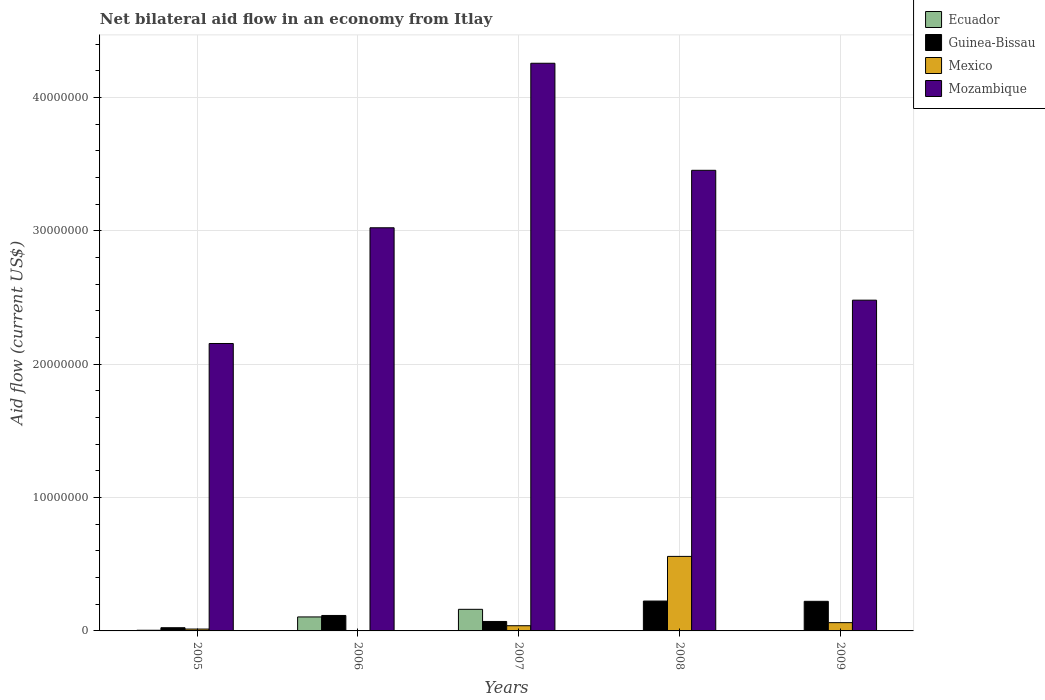How many different coloured bars are there?
Offer a terse response. 4. Are the number of bars per tick equal to the number of legend labels?
Your answer should be very brief. No. How many bars are there on the 3rd tick from the right?
Your answer should be compact. 4. What is the label of the 1st group of bars from the left?
Provide a succinct answer. 2005. In how many cases, is the number of bars for a given year not equal to the number of legend labels?
Provide a short and direct response. 2. What is the net bilateral aid flow in Mexico in 2008?
Provide a succinct answer. 5.59e+06. Across all years, what is the maximum net bilateral aid flow in Mexico?
Offer a very short reply. 5.59e+06. In which year was the net bilateral aid flow in Guinea-Bissau maximum?
Your answer should be compact. 2008. What is the total net bilateral aid flow in Ecuador in the graph?
Ensure brevity in your answer.  2.72e+06. What is the difference between the net bilateral aid flow in Mexico in 2006 and that in 2008?
Offer a terse response. -5.57e+06. What is the difference between the net bilateral aid flow in Mozambique in 2005 and the net bilateral aid flow in Mexico in 2006?
Keep it short and to the point. 2.15e+07. What is the average net bilateral aid flow in Guinea-Bissau per year?
Provide a short and direct response. 1.31e+06. In the year 2009, what is the difference between the net bilateral aid flow in Mexico and net bilateral aid flow in Guinea-Bissau?
Make the answer very short. -1.60e+06. In how many years, is the net bilateral aid flow in Ecuador greater than 38000000 US$?
Ensure brevity in your answer.  0. What is the ratio of the net bilateral aid flow in Mexico in 2005 to that in 2008?
Make the answer very short. 0.03. Is the net bilateral aid flow in Mozambique in 2006 less than that in 2007?
Provide a short and direct response. Yes. Is the difference between the net bilateral aid flow in Mexico in 2007 and 2008 greater than the difference between the net bilateral aid flow in Guinea-Bissau in 2007 and 2008?
Make the answer very short. No. What is the difference between the highest and the second highest net bilateral aid flow in Guinea-Bissau?
Keep it short and to the point. 2.00e+04. What is the difference between the highest and the lowest net bilateral aid flow in Mozambique?
Provide a short and direct response. 2.10e+07. In how many years, is the net bilateral aid flow in Ecuador greater than the average net bilateral aid flow in Ecuador taken over all years?
Offer a very short reply. 2. Is the sum of the net bilateral aid flow in Mexico in 2007 and 2009 greater than the maximum net bilateral aid flow in Mozambique across all years?
Your answer should be very brief. No. How many bars are there?
Offer a very short reply. 18. How many years are there in the graph?
Provide a succinct answer. 5. What is the difference between two consecutive major ticks on the Y-axis?
Ensure brevity in your answer.  1.00e+07. Does the graph contain grids?
Offer a terse response. Yes. Where does the legend appear in the graph?
Keep it short and to the point. Top right. What is the title of the graph?
Provide a short and direct response. Net bilateral aid flow in an economy from Itlay. Does "Central African Republic" appear as one of the legend labels in the graph?
Provide a short and direct response. No. What is the label or title of the X-axis?
Your answer should be compact. Years. What is the Aid flow (current US$) of Ecuador in 2005?
Your answer should be very brief. 5.00e+04. What is the Aid flow (current US$) in Mexico in 2005?
Give a very brief answer. 1.40e+05. What is the Aid flow (current US$) of Mozambique in 2005?
Your answer should be very brief. 2.16e+07. What is the Aid flow (current US$) in Ecuador in 2006?
Offer a very short reply. 1.05e+06. What is the Aid flow (current US$) in Guinea-Bissau in 2006?
Ensure brevity in your answer.  1.16e+06. What is the Aid flow (current US$) in Mozambique in 2006?
Offer a very short reply. 3.02e+07. What is the Aid flow (current US$) in Ecuador in 2007?
Ensure brevity in your answer.  1.62e+06. What is the Aid flow (current US$) of Guinea-Bissau in 2007?
Provide a short and direct response. 7.10e+05. What is the Aid flow (current US$) of Mexico in 2007?
Make the answer very short. 3.90e+05. What is the Aid flow (current US$) of Mozambique in 2007?
Provide a succinct answer. 4.26e+07. What is the Aid flow (current US$) in Guinea-Bissau in 2008?
Offer a terse response. 2.24e+06. What is the Aid flow (current US$) of Mexico in 2008?
Provide a short and direct response. 5.59e+06. What is the Aid flow (current US$) in Mozambique in 2008?
Your answer should be very brief. 3.46e+07. What is the Aid flow (current US$) of Guinea-Bissau in 2009?
Ensure brevity in your answer.  2.22e+06. What is the Aid flow (current US$) of Mexico in 2009?
Your answer should be compact. 6.20e+05. What is the Aid flow (current US$) in Mozambique in 2009?
Keep it short and to the point. 2.48e+07. Across all years, what is the maximum Aid flow (current US$) of Ecuador?
Your response must be concise. 1.62e+06. Across all years, what is the maximum Aid flow (current US$) in Guinea-Bissau?
Your response must be concise. 2.24e+06. Across all years, what is the maximum Aid flow (current US$) in Mexico?
Your answer should be compact. 5.59e+06. Across all years, what is the maximum Aid flow (current US$) in Mozambique?
Your response must be concise. 4.26e+07. Across all years, what is the minimum Aid flow (current US$) of Ecuador?
Offer a terse response. 0. Across all years, what is the minimum Aid flow (current US$) of Guinea-Bissau?
Your response must be concise. 2.40e+05. Across all years, what is the minimum Aid flow (current US$) of Mozambique?
Give a very brief answer. 2.16e+07. What is the total Aid flow (current US$) of Ecuador in the graph?
Your answer should be compact. 2.72e+06. What is the total Aid flow (current US$) in Guinea-Bissau in the graph?
Offer a terse response. 6.57e+06. What is the total Aid flow (current US$) of Mexico in the graph?
Offer a terse response. 6.76e+06. What is the total Aid flow (current US$) of Mozambique in the graph?
Give a very brief answer. 1.54e+08. What is the difference between the Aid flow (current US$) in Guinea-Bissau in 2005 and that in 2006?
Keep it short and to the point. -9.20e+05. What is the difference between the Aid flow (current US$) in Mexico in 2005 and that in 2006?
Provide a short and direct response. 1.20e+05. What is the difference between the Aid flow (current US$) of Mozambique in 2005 and that in 2006?
Your answer should be very brief. -8.68e+06. What is the difference between the Aid flow (current US$) in Ecuador in 2005 and that in 2007?
Your answer should be compact. -1.57e+06. What is the difference between the Aid flow (current US$) of Guinea-Bissau in 2005 and that in 2007?
Keep it short and to the point. -4.70e+05. What is the difference between the Aid flow (current US$) of Mexico in 2005 and that in 2007?
Make the answer very short. -2.50e+05. What is the difference between the Aid flow (current US$) of Mozambique in 2005 and that in 2007?
Ensure brevity in your answer.  -2.10e+07. What is the difference between the Aid flow (current US$) of Guinea-Bissau in 2005 and that in 2008?
Make the answer very short. -2.00e+06. What is the difference between the Aid flow (current US$) in Mexico in 2005 and that in 2008?
Keep it short and to the point. -5.45e+06. What is the difference between the Aid flow (current US$) of Mozambique in 2005 and that in 2008?
Your answer should be compact. -1.30e+07. What is the difference between the Aid flow (current US$) in Guinea-Bissau in 2005 and that in 2009?
Your answer should be very brief. -1.98e+06. What is the difference between the Aid flow (current US$) in Mexico in 2005 and that in 2009?
Ensure brevity in your answer.  -4.80e+05. What is the difference between the Aid flow (current US$) in Mozambique in 2005 and that in 2009?
Your response must be concise. -3.25e+06. What is the difference between the Aid flow (current US$) in Ecuador in 2006 and that in 2007?
Make the answer very short. -5.70e+05. What is the difference between the Aid flow (current US$) of Guinea-Bissau in 2006 and that in 2007?
Provide a succinct answer. 4.50e+05. What is the difference between the Aid flow (current US$) in Mexico in 2006 and that in 2007?
Your answer should be compact. -3.70e+05. What is the difference between the Aid flow (current US$) in Mozambique in 2006 and that in 2007?
Make the answer very short. -1.23e+07. What is the difference between the Aid flow (current US$) of Guinea-Bissau in 2006 and that in 2008?
Your answer should be compact. -1.08e+06. What is the difference between the Aid flow (current US$) in Mexico in 2006 and that in 2008?
Ensure brevity in your answer.  -5.57e+06. What is the difference between the Aid flow (current US$) of Mozambique in 2006 and that in 2008?
Give a very brief answer. -4.31e+06. What is the difference between the Aid flow (current US$) in Guinea-Bissau in 2006 and that in 2009?
Your answer should be very brief. -1.06e+06. What is the difference between the Aid flow (current US$) of Mexico in 2006 and that in 2009?
Ensure brevity in your answer.  -6.00e+05. What is the difference between the Aid flow (current US$) of Mozambique in 2006 and that in 2009?
Ensure brevity in your answer.  5.43e+06. What is the difference between the Aid flow (current US$) in Guinea-Bissau in 2007 and that in 2008?
Provide a succinct answer. -1.53e+06. What is the difference between the Aid flow (current US$) of Mexico in 2007 and that in 2008?
Provide a succinct answer. -5.20e+06. What is the difference between the Aid flow (current US$) of Mozambique in 2007 and that in 2008?
Make the answer very short. 8.03e+06. What is the difference between the Aid flow (current US$) of Guinea-Bissau in 2007 and that in 2009?
Provide a short and direct response. -1.51e+06. What is the difference between the Aid flow (current US$) of Mozambique in 2007 and that in 2009?
Offer a terse response. 1.78e+07. What is the difference between the Aid flow (current US$) of Mexico in 2008 and that in 2009?
Keep it short and to the point. 4.97e+06. What is the difference between the Aid flow (current US$) in Mozambique in 2008 and that in 2009?
Give a very brief answer. 9.74e+06. What is the difference between the Aid flow (current US$) in Ecuador in 2005 and the Aid flow (current US$) in Guinea-Bissau in 2006?
Your answer should be compact. -1.11e+06. What is the difference between the Aid flow (current US$) in Ecuador in 2005 and the Aid flow (current US$) in Mozambique in 2006?
Provide a short and direct response. -3.02e+07. What is the difference between the Aid flow (current US$) in Guinea-Bissau in 2005 and the Aid flow (current US$) in Mozambique in 2006?
Give a very brief answer. -3.00e+07. What is the difference between the Aid flow (current US$) of Mexico in 2005 and the Aid flow (current US$) of Mozambique in 2006?
Provide a short and direct response. -3.01e+07. What is the difference between the Aid flow (current US$) of Ecuador in 2005 and the Aid flow (current US$) of Guinea-Bissau in 2007?
Your answer should be very brief. -6.60e+05. What is the difference between the Aid flow (current US$) of Ecuador in 2005 and the Aid flow (current US$) of Mozambique in 2007?
Your answer should be compact. -4.25e+07. What is the difference between the Aid flow (current US$) in Guinea-Bissau in 2005 and the Aid flow (current US$) in Mozambique in 2007?
Give a very brief answer. -4.23e+07. What is the difference between the Aid flow (current US$) of Mexico in 2005 and the Aid flow (current US$) of Mozambique in 2007?
Your answer should be compact. -4.24e+07. What is the difference between the Aid flow (current US$) in Ecuador in 2005 and the Aid flow (current US$) in Guinea-Bissau in 2008?
Provide a short and direct response. -2.19e+06. What is the difference between the Aid flow (current US$) in Ecuador in 2005 and the Aid flow (current US$) in Mexico in 2008?
Keep it short and to the point. -5.54e+06. What is the difference between the Aid flow (current US$) of Ecuador in 2005 and the Aid flow (current US$) of Mozambique in 2008?
Give a very brief answer. -3.45e+07. What is the difference between the Aid flow (current US$) in Guinea-Bissau in 2005 and the Aid flow (current US$) in Mexico in 2008?
Provide a succinct answer. -5.35e+06. What is the difference between the Aid flow (current US$) of Guinea-Bissau in 2005 and the Aid flow (current US$) of Mozambique in 2008?
Give a very brief answer. -3.43e+07. What is the difference between the Aid flow (current US$) in Mexico in 2005 and the Aid flow (current US$) in Mozambique in 2008?
Your answer should be very brief. -3.44e+07. What is the difference between the Aid flow (current US$) in Ecuador in 2005 and the Aid flow (current US$) in Guinea-Bissau in 2009?
Keep it short and to the point. -2.17e+06. What is the difference between the Aid flow (current US$) of Ecuador in 2005 and the Aid flow (current US$) of Mexico in 2009?
Keep it short and to the point. -5.70e+05. What is the difference between the Aid flow (current US$) of Ecuador in 2005 and the Aid flow (current US$) of Mozambique in 2009?
Your answer should be very brief. -2.48e+07. What is the difference between the Aid flow (current US$) of Guinea-Bissau in 2005 and the Aid flow (current US$) of Mexico in 2009?
Keep it short and to the point. -3.80e+05. What is the difference between the Aid flow (current US$) in Guinea-Bissau in 2005 and the Aid flow (current US$) in Mozambique in 2009?
Keep it short and to the point. -2.46e+07. What is the difference between the Aid flow (current US$) in Mexico in 2005 and the Aid flow (current US$) in Mozambique in 2009?
Offer a very short reply. -2.47e+07. What is the difference between the Aid flow (current US$) in Ecuador in 2006 and the Aid flow (current US$) in Guinea-Bissau in 2007?
Offer a terse response. 3.40e+05. What is the difference between the Aid flow (current US$) in Ecuador in 2006 and the Aid flow (current US$) in Mozambique in 2007?
Provide a succinct answer. -4.15e+07. What is the difference between the Aid flow (current US$) in Guinea-Bissau in 2006 and the Aid flow (current US$) in Mexico in 2007?
Provide a succinct answer. 7.70e+05. What is the difference between the Aid flow (current US$) of Guinea-Bissau in 2006 and the Aid flow (current US$) of Mozambique in 2007?
Provide a short and direct response. -4.14e+07. What is the difference between the Aid flow (current US$) of Mexico in 2006 and the Aid flow (current US$) of Mozambique in 2007?
Offer a terse response. -4.26e+07. What is the difference between the Aid flow (current US$) in Ecuador in 2006 and the Aid flow (current US$) in Guinea-Bissau in 2008?
Give a very brief answer. -1.19e+06. What is the difference between the Aid flow (current US$) in Ecuador in 2006 and the Aid flow (current US$) in Mexico in 2008?
Provide a short and direct response. -4.54e+06. What is the difference between the Aid flow (current US$) in Ecuador in 2006 and the Aid flow (current US$) in Mozambique in 2008?
Offer a very short reply. -3.35e+07. What is the difference between the Aid flow (current US$) in Guinea-Bissau in 2006 and the Aid flow (current US$) in Mexico in 2008?
Offer a very short reply. -4.43e+06. What is the difference between the Aid flow (current US$) of Guinea-Bissau in 2006 and the Aid flow (current US$) of Mozambique in 2008?
Make the answer very short. -3.34e+07. What is the difference between the Aid flow (current US$) of Mexico in 2006 and the Aid flow (current US$) of Mozambique in 2008?
Offer a very short reply. -3.45e+07. What is the difference between the Aid flow (current US$) of Ecuador in 2006 and the Aid flow (current US$) of Guinea-Bissau in 2009?
Give a very brief answer. -1.17e+06. What is the difference between the Aid flow (current US$) in Ecuador in 2006 and the Aid flow (current US$) in Mozambique in 2009?
Make the answer very short. -2.38e+07. What is the difference between the Aid flow (current US$) in Guinea-Bissau in 2006 and the Aid flow (current US$) in Mexico in 2009?
Make the answer very short. 5.40e+05. What is the difference between the Aid flow (current US$) of Guinea-Bissau in 2006 and the Aid flow (current US$) of Mozambique in 2009?
Ensure brevity in your answer.  -2.36e+07. What is the difference between the Aid flow (current US$) of Mexico in 2006 and the Aid flow (current US$) of Mozambique in 2009?
Make the answer very short. -2.48e+07. What is the difference between the Aid flow (current US$) in Ecuador in 2007 and the Aid flow (current US$) in Guinea-Bissau in 2008?
Provide a short and direct response. -6.20e+05. What is the difference between the Aid flow (current US$) of Ecuador in 2007 and the Aid flow (current US$) of Mexico in 2008?
Provide a short and direct response. -3.97e+06. What is the difference between the Aid flow (current US$) of Ecuador in 2007 and the Aid flow (current US$) of Mozambique in 2008?
Keep it short and to the point. -3.29e+07. What is the difference between the Aid flow (current US$) in Guinea-Bissau in 2007 and the Aid flow (current US$) in Mexico in 2008?
Make the answer very short. -4.88e+06. What is the difference between the Aid flow (current US$) of Guinea-Bissau in 2007 and the Aid flow (current US$) of Mozambique in 2008?
Provide a succinct answer. -3.38e+07. What is the difference between the Aid flow (current US$) of Mexico in 2007 and the Aid flow (current US$) of Mozambique in 2008?
Your response must be concise. -3.42e+07. What is the difference between the Aid flow (current US$) in Ecuador in 2007 and the Aid flow (current US$) in Guinea-Bissau in 2009?
Keep it short and to the point. -6.00e+05. What is the difference between the Aid flow (current US$) in Ecuador in 2007 and the Aid flow (current US$) in Mozambique in 2009?
Offer a very short reply. -2.32e+07. What is the difference between the Aid flow (current US$) of Guinea-Bissau in 2007 and the Aid flow (current US$) of Mozambique in 2009?
Your response must be concise. -2.41e+07. What is the difference between the Aid flow (current US$) in Mexico in 2007 and the Aid flow (current US$) in Mozambique in 2009?
Keep it short and to the point. -2.44e+07. What is the difference between the Aid flow (current US$) of Guinea-Bissau in 2008 and the Aid flow (current US$) of Mexico in 2009?
Make the answer very short. 1.62e+06. What is the difference between the Aid flow (current US$) in Guinea-Bissau in 2008 and the Aid flow (current US$) in Mozambique in 2009?
Offer a terse response. -2.26e+07. What is the difference between the Aid flow (current US$) of Mexico in 2008 and the Aid flow (current US$) of Mozambique in 2009?
Your response must be concise. -1.92e+07. What is the average Aid flow (current US$) of Ecuador per year?
Make the answer very short. 5.44e+05. What is the average Aid flow (current US$) in Guinea-Bissau per year?
Provide a succinct answer. 1.31e+06. What is the average Aid flow (current US$) in Mexico per year?
Offer a very short reply. 1.35e+06. What is the average Aid flow (current US$) in Mozambique per year?
Keep it short and to the point. 3.07e+07. In the year 2005, what is the difference between the Aid flow (current US$) in Ecuador and Aid flow (current US$) in Mozambique?
Your answer should be compact. -2.15e+07. In the year 2005, what is the difference between the Aid flow (current US$) of Guinea-Bissau and Aid flow (current US$) of Mozambique?
Your answer should be compact. -2.13e+07. In the year 2005, what is the difference between the Aid flow (current US$) of Mexico and Aid flow (current US$) of Mozambique?
Offer a terse response. -2.14e+07. In the year 2006, what is the difference between the Aid flow (current US$) in Ecuador and Aid flow (current US$) in Mexico?
Your response must be concise. 1.03e+06. In the year 2006, what is the difference between the Aid flow (current US$) of Ecuador and Aid flow (current US$) of Mozambique?
Your answer should be compact. -2.92e+07. In the year 2006, what is the difference between the Aid flow (current US$) of Guinea-Bissau and Aid flow (current US$) of Mexico?
Your response must be concise. 1.14e+06. In the year 2006, what is the difference between the Aid flow (current US$) in Guinea-Bissau and Aid flow (current US$) in Mozambique?
Keep it short and to the point. -2.91e+07. In the year 2006, what is the difference between the Aid flow (current US$) in Mexico and Aid flow (current US$) in Mozambique?
Keep it short and to the point. -3.02e+07. In the year 2007, what is the difference between the Aid flow (current US$) of Ecuador and Aid flow (current US$) of Guinea-Bissau?
Your answer should be compact. 9.10e+05. In the year 2007, what is the difference between the Aid flow (current US$) in Ecuador and Aid flow (current US$) in Mexico?
Provide a short and direct response. 1.23e+06. In the year 2007, what is the difference between the Aid flow (current US$) in Ecuador and Aid flow (current US$) in Mozambique?
Provide a short and direct response. -4.10e+07. In the year 2007, what is the difference between the Aid flow (current US$) in Guinea-Bissau and Aid flow (current US$) in Mozambique?
Your answer should be compact. -4.19e+07. In the year 2007, what is the difference between the Aid flow (current US$) of Mexico and Aid flow (current US$) of Mozambique?
Offer a terse response. -4.22e+07. In the year 2008, what is the difference between the Aid flow (current US$) in Guinea-Bissau and Aid flow (current US$) in Mexico?
Your response must be concise. -3.35e+06. In the year 2008, what is the difference between the Aid flow (current US$) in Guinea-Bissau and Aid flow (current US$) in Mozambique?
Provide a short and direct response. -3.23e+07. In the year 2008, what is the difference between the Aid flow (current US$) in Mexico and Aid flow (current US$) in Mozambique?
Ensure brevity in your answer.  -2.90e+07. In the year 2009, what is the difference between the Aid flow (current US$) in Guinea-Bissau and Aid flow (current US$) in Mexico?
Provide a succinct answer. 1.60e+06. In the year 2009, what is the difference between the Aid flow (current US$) in Guinea-Bissau and Aid flow (current US$) in Mozambique?
Provide a short and direct response. -2.26e+07. In the year 2009, what is the difference between the Aid flow (current US$) of Mexico and Aid flow (current US$) of Mozambique?
Ensure brevity in your answer.  -2.42e+07. What is the ratio of the Aid flow (current US$) of Ecuador in 2005 to that in 2006?
Make the answer very short. 0.05. What is the ratio of the Aid flow (current US$) in Guinea-Bissau in 2005 to that in 2006?
Offer a terse response. 0.21. What is the ratio of the Aid flow (current US$) in Mexico in 2005 to that in 2006?
Offer a very short reply. 7. What is the ratio of the Aid flow (current US$) of Mozambique in 2005 to that in 2006?
Your answer should be compact. 0.71. What is the ratio of the Aid flow (current US$) of Ecuador in 2005 to that in 2007?
Keep it short and to the point. 0.03. What is the ratio of the Aid flow (current US$) in Guinea-Bissau in 2005 to that in 2007?
Make the answer very short. 0.34. What is the ratio of the Aid flow (current US$) in Mexico in 2005 to that in 2007?
Make the answer very short. 0.36. What is the ratio of the Aid flow (current US$) in Mozambique in 2005 to that in 2007?
Give a very brief answer. 0.51. What is the ratio of the Aid flow (current US$) in Guinea-Bissau in 2005 to that in 2008?
Keep it short and to the point. 0.11. What is the ratio of the Aid flow (current US$) of Mexico in 2005 to that in 2008?
Give a very brief answer. 0.03. What is the ratio of the Aid flow (current US$) in Mozambique in 2005 to that in 2008?
Give a very brief answer. 0.62. What is the ratio of the Aid flow (current US$) in Guinea-Bissau in 2005 to that in 2009?
Provide a short and direct response. 0.11. What is the ratio of the Aid flow (current US$) in Mexico in 2005 to that in 2009?
Make the answer very short. 0.23. What is the ratio of the Aid flow (current US$) in Mozambique in 2005 to that in 2009?
Your answer should be compact. 0.87. What is the ratio of the Aid flow (current US$) in Ecuador in 2006 to that in 2007?
Give a very brief answer. 0.65. What is the ratio of the Aid flow (current US$) of Guinea-Bissau in 2006 to that in 2007?
Offer a very short reply. 1.63. What is the ratio of the Aid flow (current US$) of Mexico in 2006 to that in 2007?
Provide a succinct answer. 0.05. What is the ratio of the Aid flow (current US$) in Mozambique in 2006 to that in 2007?
Your answer should be compact. 0.71. What is the ratio of the Aid flow (current US$) of Guinea-Bissau in 2006 to that in 2008?
Provide a short and direct response. 0.52. What is the ratio of the Aid flow (current US$) of Mexico in 2006 to that in 2008?
Your answer should be compact. 0. What is the ratio of the Aid flow (current US$) of Mozambique in 2006 to that in 2008?
Provide a succinct answer. 0.88. What is the ratio of the Aid flow (current US$) in Guinea-Bissau in 2006 to that in 2009?
Keep it short and to the point. 0.52. What is the ratio of the Aid flow (current US$) in Mexico in 2006 to that in 2009?
Give a very brief answer. 0.03. What is the ratio of the Aid flow (current US$) of Mozambique in 2006 to that in 2009?
Provide a succinct answer. 1.22. What is the ratio of the Aid flow (current US$) in Guinea-Bissau in 2007 to that in 2008?
Provide a succinct answer. 0.32. What is the ratio of the Aid flow (current US$) of Mexico in 2007 to that in 2008?
Make the answer very short. 0.07. What is the ratio of the Aid flow (current US$) in Mozambique in 2007 to that in 2008?
Your answer should be very brief. 1.23. What is the ratio of the Aid flow (current US$) in Guinea-Bissau in 2007 to that in 2009?
Offer a very short reply. 0.32. What is the ratio of the Aid flow (current US$) of Mexico in 2007 to that in 2009?
Give a very brief answer. 0.63. What is the ratio of the Aid flow (current US$) of Mozambique in 2007 to that in 2009?
Your answer should be very brief. 1.72. What is the ratio of the Aid flow (current US$) of Guinea-Bissau in 2008 to that in 2009?
Make the answer very short. 1.01. What is the ratio of the Aid flow (current US$) in Mexico in 2008 to that in 2009?
Offer a terse response. 9.02. What is the ratio of the Aid flow (current US$) of Mozambique in 2008 to that in 2009?
Give a very brief answer. 1.39. What is the difference between the highest and the second highest Aid flow (current US$) in Ecuador?
Give a very brief answer. 5.70e+05. What is the difference between the highest and the second highest Aid flow (current US$) in Guinea-Bissau?
Give a very brief answer. 2.00e+04. What is the difference between the highest and the second highest Aid flow (current US$) in Mexico?
Provide a short and direct response. 4.97e+06. What is the difference between the highest and the second highest Aid flow (current US$) in Mozambique?
Offer a terse response. 8.03e+06. What is the difference between the highest and the lowest Aid flow (current US$) in Ecuador?
Ensure brevity in your answer.  1.62e+06. What is the difference between the highest and the lowest Aid flow (current US$) in Guinea-Bissau?
Offer a terse response. 2.00e+06. What is the difference between the highest and the lowest Aid flow (current US$) of Mexico?
Make the answer very short. 5.57e+06. What is the difference between the highest and the lowest Aid flow (current US$) of Mozambique?
Your response must be concise. 2.10e+07. 